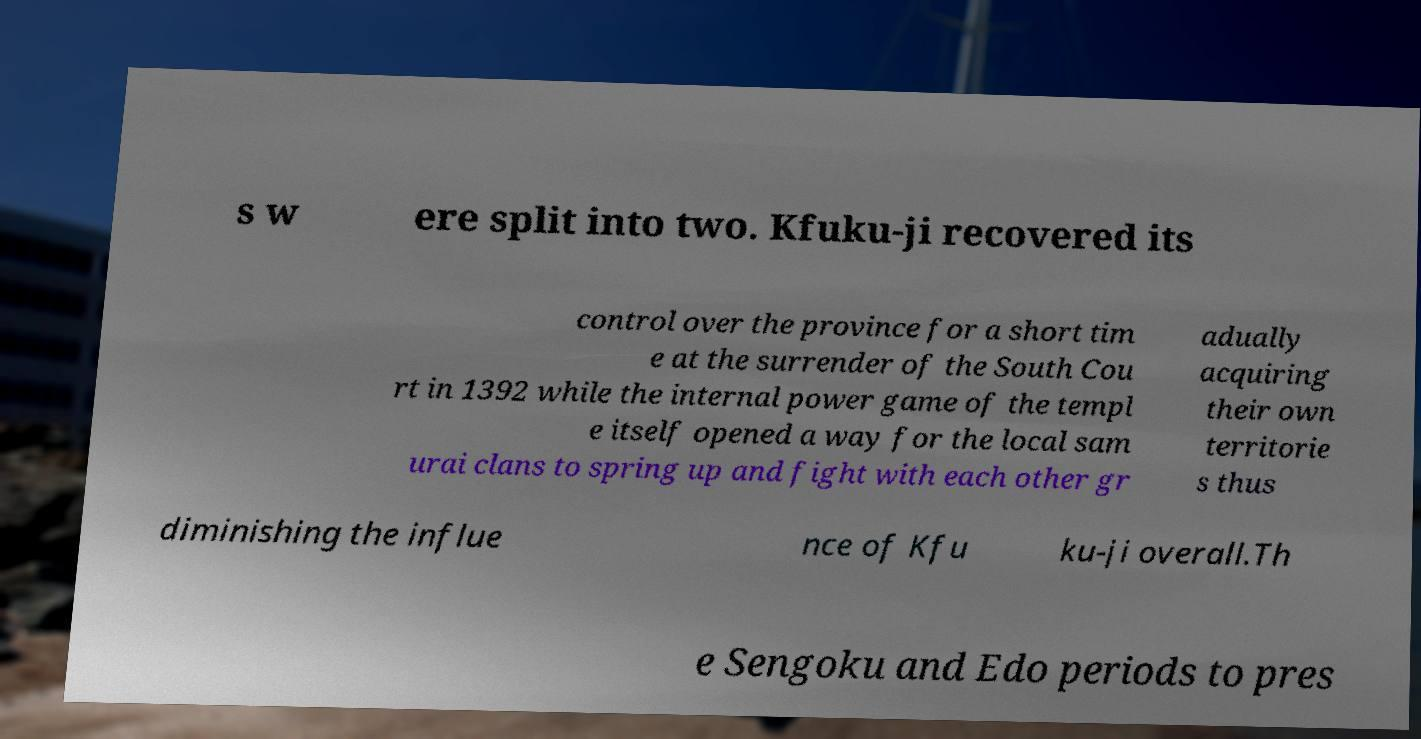For documentation purposes, I need the text within this image transcribed. Could you provide that? s w ere split into two. Kfuku-ji recovered its control over the province for a short tim e at the surrender of the South Cou rt in 1392 while the internal power game of the templ e itself opened a way for the local sam urai clans to spring up and fight with each other gr adually acquiring their own territorie s thus diminishing the influe nce of Kfu ku-ji overall.Th e Sengoku and Edo periods to pres 